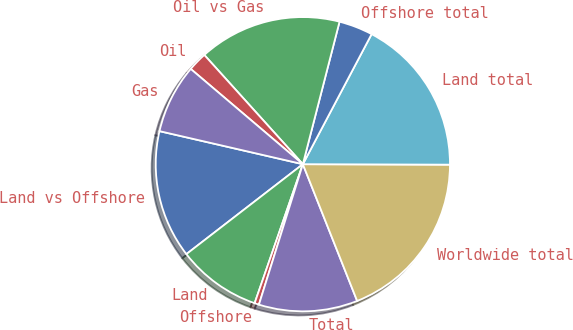Convert chart. <chart><loc_0><loc_0><loc_500><loc_500><pie_chart><fcel>Land vs Offshore<fcel>Land<fcel>Offshore<fcel>Total<fcel>Worldwide total<fcel>Land total<fcel>Offshore total<fcel>Oil vs Gas<fcel>Oil<fcel>Gas<nl><fcel>14.07%<fcel>9.22%<fcel>0.49%<fcel>10.84%<fcel>18.93%<fcel>17.31%<fcel>3.73%<fcel>15.69%<fcel>2.11%<fcel>7.6%<nl></chart> 